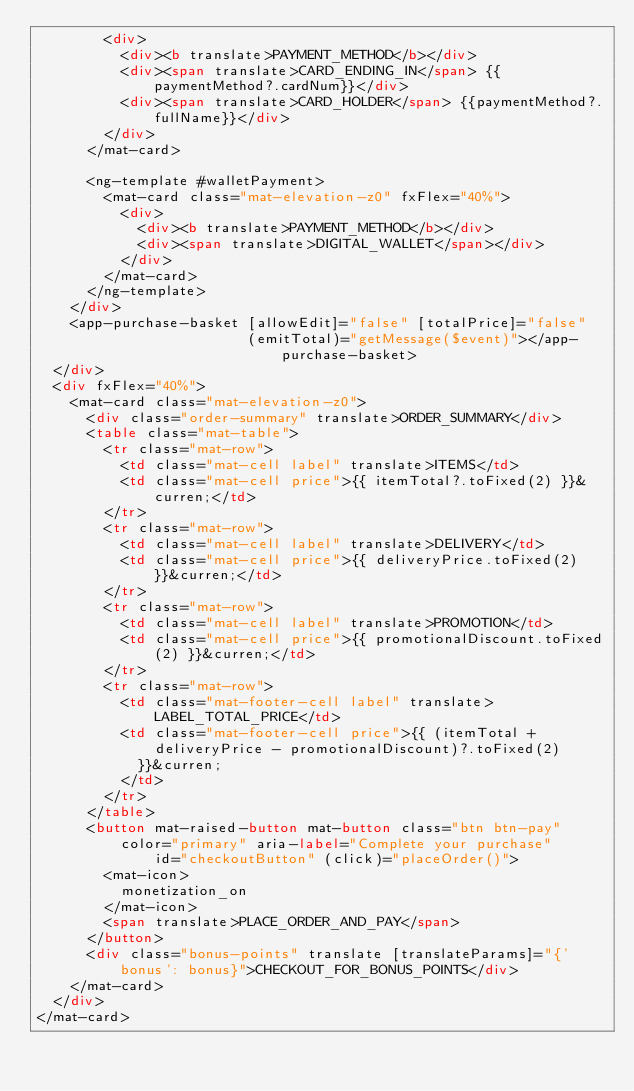Convert code to text. <code><loc_0><loc_0><loc_500><loc_500><_HTML_>        <div>
          <div><b translate>PAYMENT_METHOD</b></div>
          <div><span translate>CARD_ENDING_IN</span> {{paymentMethod?.cardNum}}</div>
          <div><span translate>CARD_HOLDER</span> {{paymentMethod?.fullName}}</div>
        </div>
      </mat-card>

      <ng-template #walletPayment>
        <mat-card class="mat-elevation-z0" fxFlex="40%">
          <div>
            <div><b translate>PAYMENT_METHOD</b></div>
            <div><span translate>DIGITAL_WALLET</span></div>
          </div>
        </mat-card>
      </ng-template>
    </div>
    <app-purchase-basket [allowEdit]="false" [totalPrice]="false"
                         (emitTotal)="getMessage($event)"></app-purchase-basket>
  </div>
  <div fxFlex="40%">
    <mat-card class="mat-elevation-z0">
      <div class="order-summary" translate>ORDER_SUMMARY</div>
      <table class="mat-table">
        <tr class="mat-row">
          <td class="mat-cell label" translate>ITEMS</td>
          <td class="mat-cell price">{{ itemTotal?.toFixed(2) }}&curren;</td>
        </tr>
        <tr class="mat-row">
          <td class="mat-cell label" translate>DELIVERY</td>
          <td class="mat-cell price">{{ deliveryPrice.toFixed(2) }}&curren;</td>
        </tr>
        <tr class="mat-row">
          <td class="mat-cell label" translate>PROMOTION</td>
          <td class="mat-cell price">{{ promotionalDiscount.toFixed(2) }}&curren;</td>
        </tr>
        <tr class="mat-row">
          <td class="mat-footer-cell label" translate>LABEL_TOTAL_PRICE</td>
          <td class="mat-footer-cell price">{{ (itemTotal + deliveryPrice - promotionalDiscount)?.toFixed(2)
            }}&curren;
          </td>
        </tr>
      </table>
      <button mat-raised-button mat-button class="btn btn-pay" color="primary" aria-label="Complete your purchase"
              id="checkoutButton" (click)="placeOrder()">
        <mat-icon>
          monetization_on
        </mat-icon>
        <span translate>PLACE_ORDER_AND_PAY</span>
      </button>
      <div class="bonus-points" translate [translateParams]="{'bonus': bonus}">CHECKOUT_FOR_BONUS_POINTS</div>
    </mat-card>
  </div>
</mat-card>
</code> 